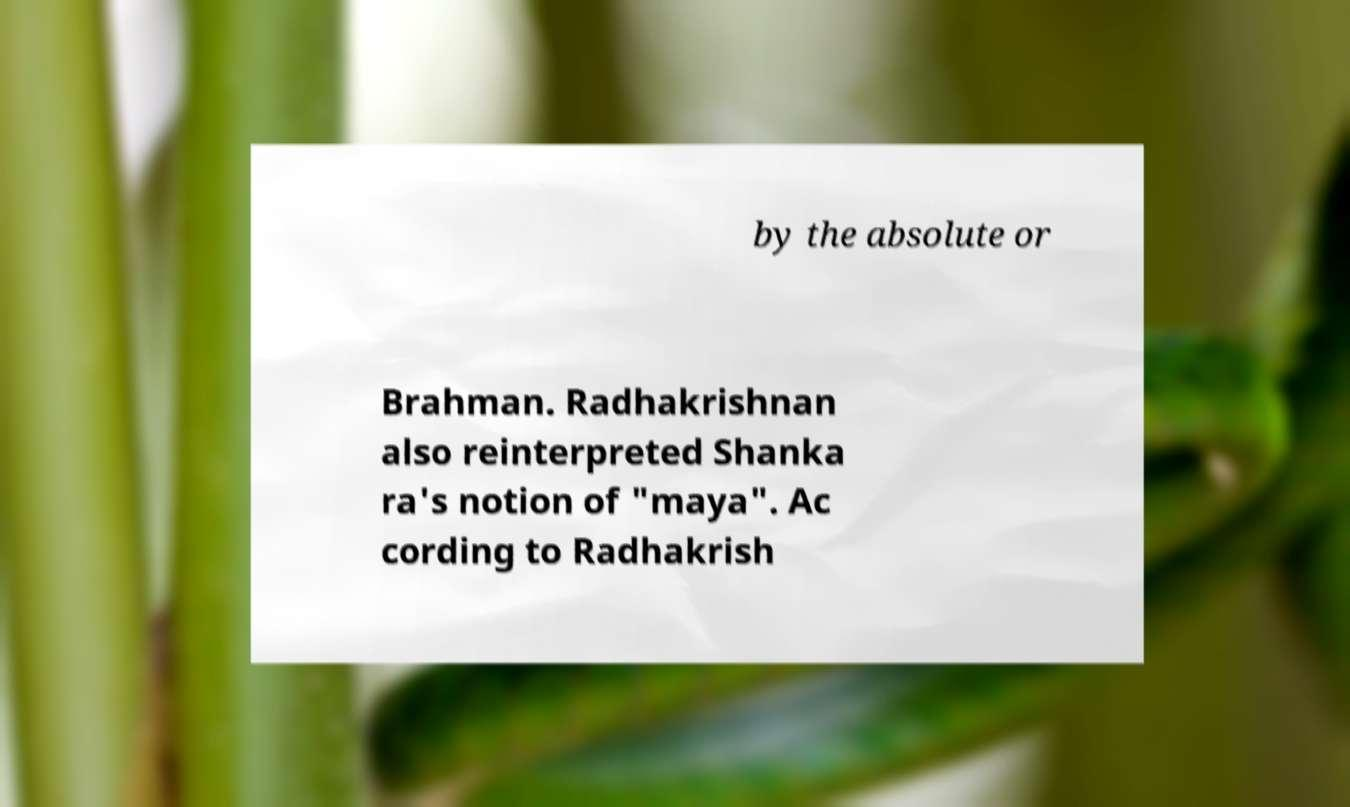What messages or text are displayed in this image? I need them in a readable, typed format. by the absolute or Brahman. Radhakrishnan also reinterpreted Shanka ra's notion of "maya". Ac cording to Radhakrish 